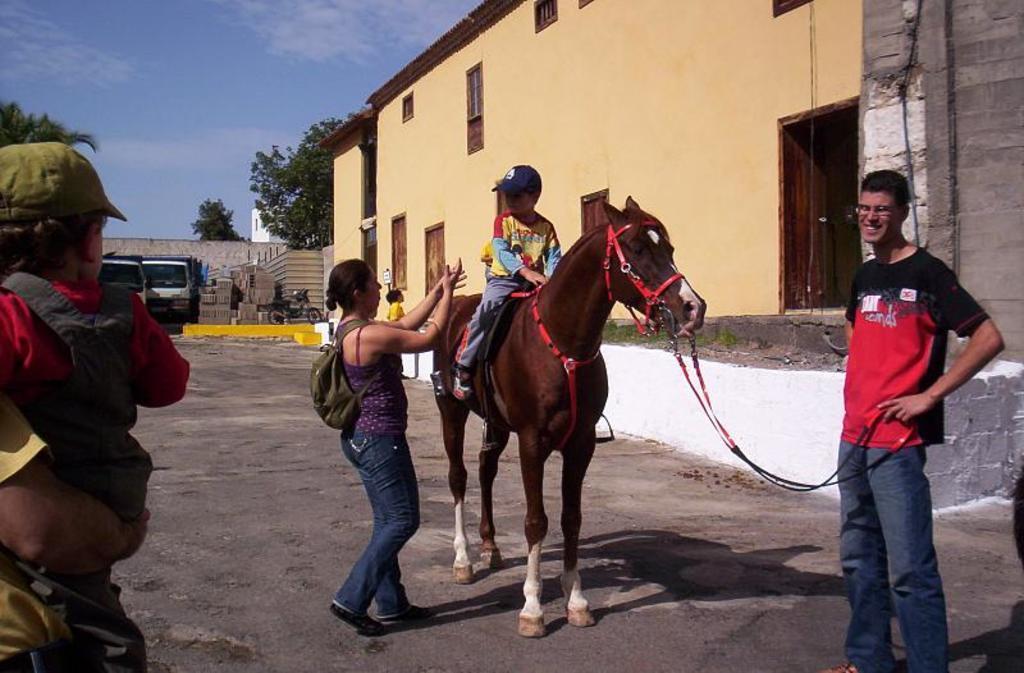Please provide a concise description of this image. Here there is horse ,boy is sitting on the horse,woman walking carrying a bag,this person is holding the horse and this person is carrying a baby,in back there are trees,building,vehicle,sky. 